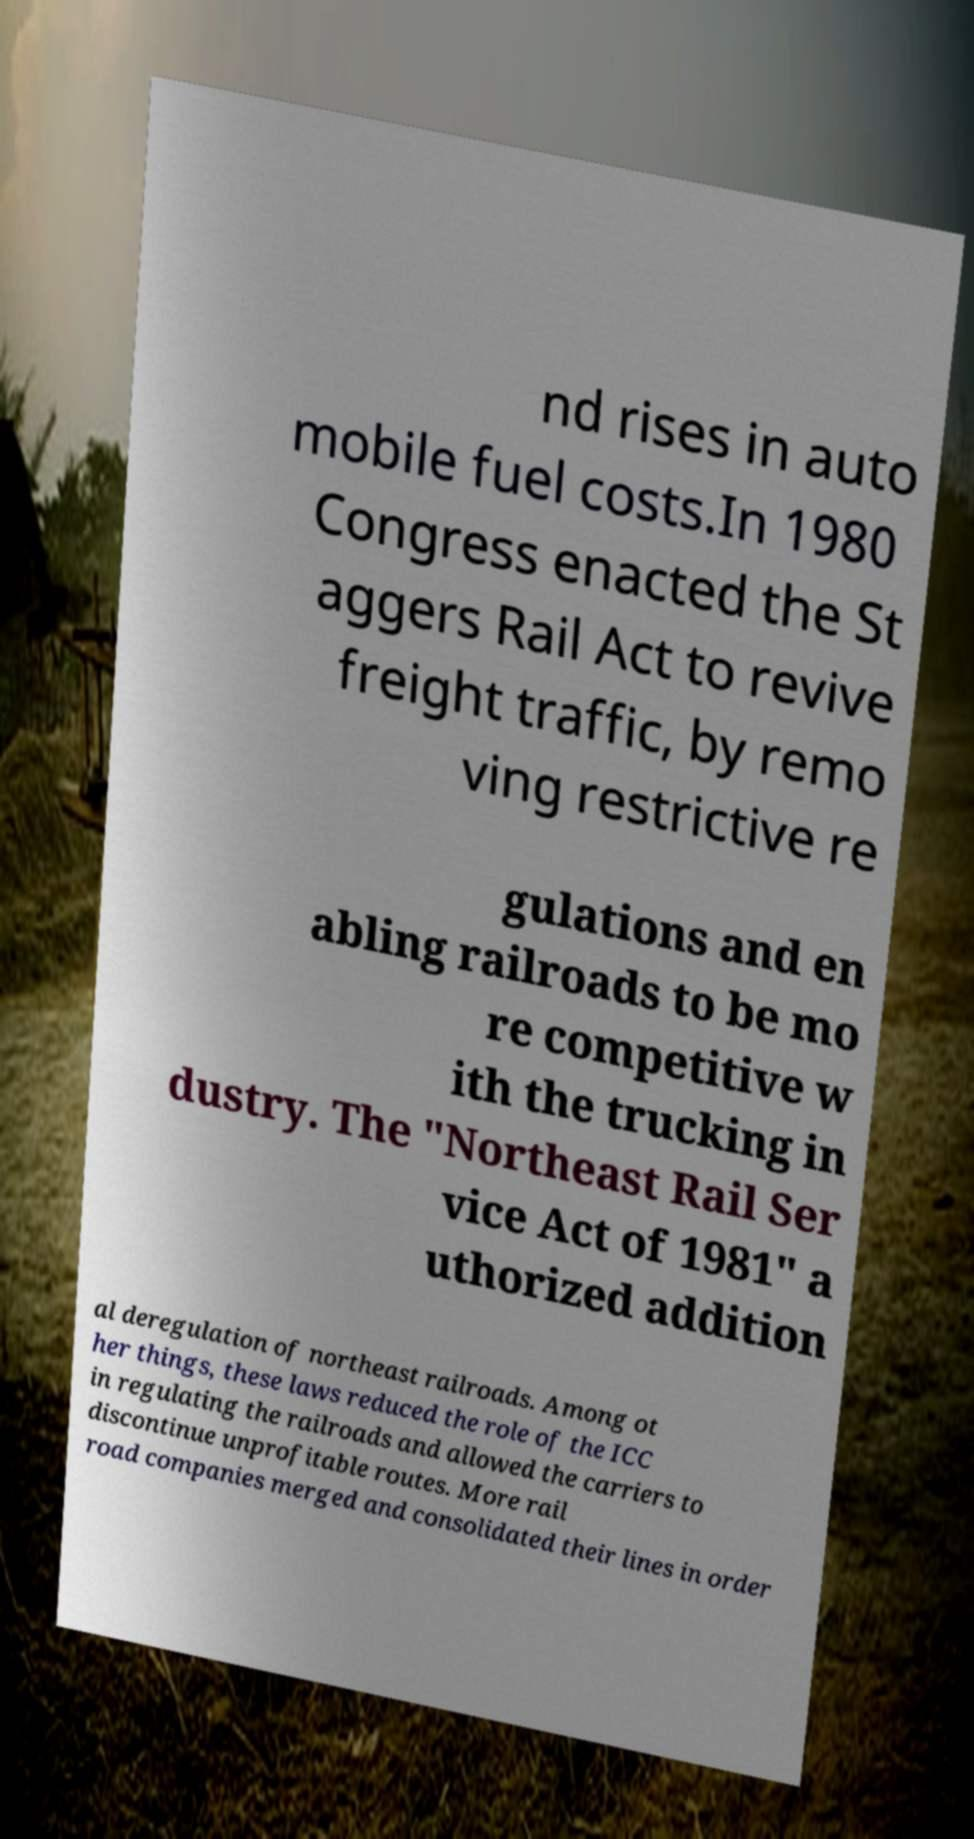Please read and relay the text visible in this image. What does it say? nd rises in auto mobile fuel costs.In 1980 Congress enacted the St aggers Rail Act to revive freight traffic, by remo ving restrictive re gulations and en abling railroads to be mo re competitive w ith the trucking in dustry. The "Northeast Rail Ser vice Act of 1981" a uthorized addition al deregulation of northeast railroads. Among ot her things, these laws reduced the role of the ICC in regulating the railroads and allowed the carriers to discontinue unprofitable routes. More rail road companies merged and consolidated their lines in order 